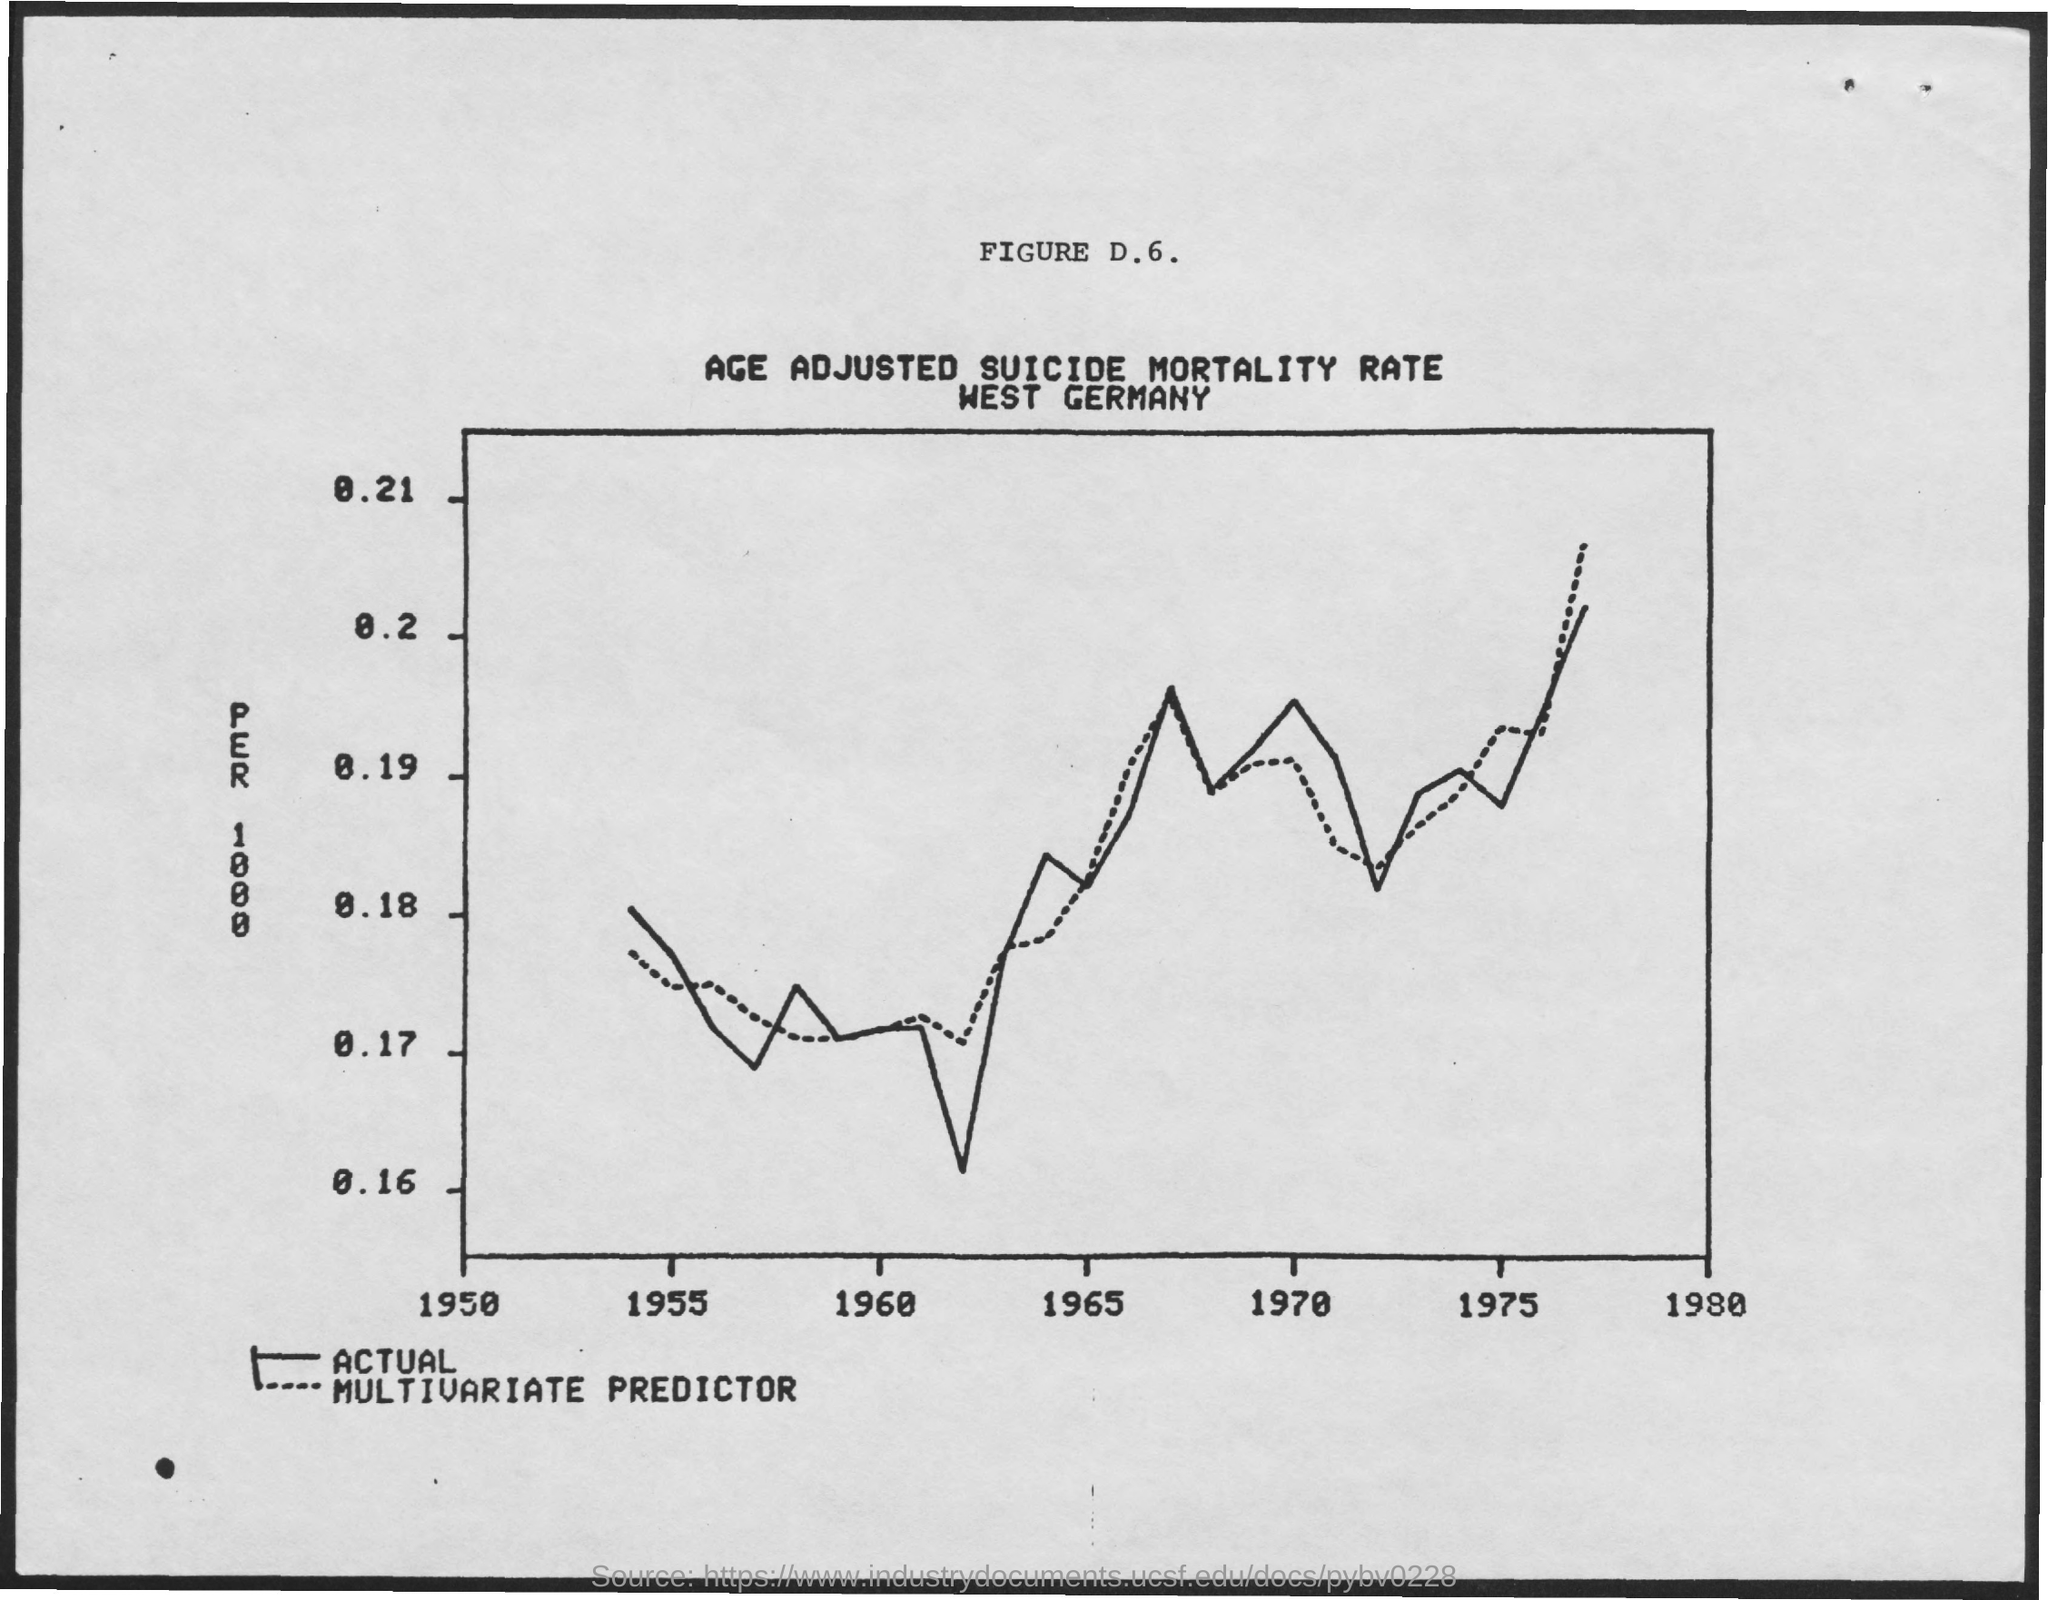Give some essential details in this illustration. The country mentioned in the document is West Germany. 